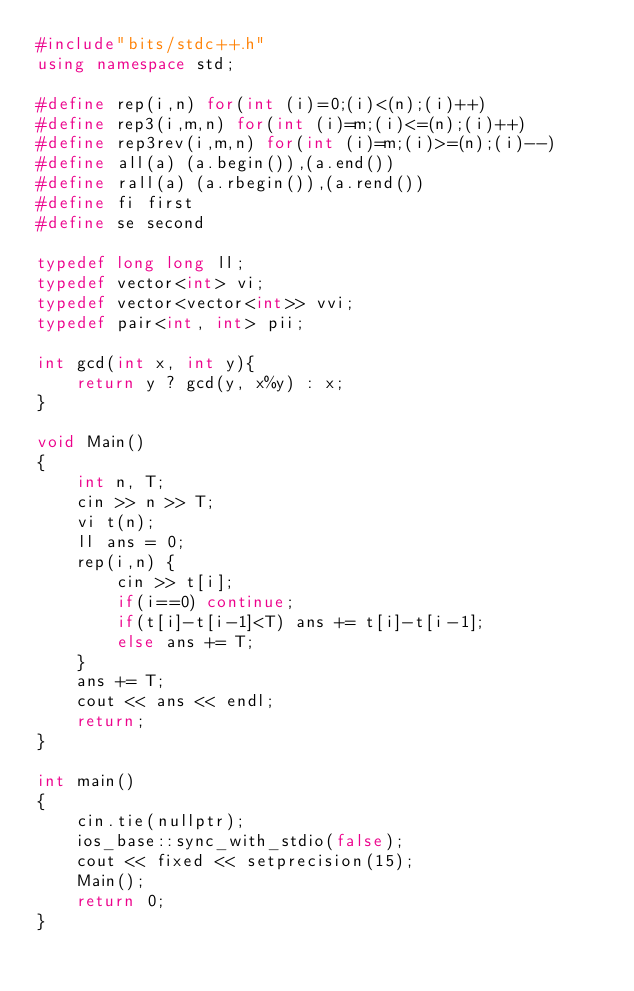<code> <loc_0><loc_0><loc_500><loc_500><_C++_>#include"bits/stdc++.h"
using namespace std;

#define rep(i,n) for(int (i)=0;(i)<(n);(i)++)
#define rep3(i,m,n) for(int (i)=m;(i)<=(n);(i)++)
#define rep3rev(i,m,n) for(int (i)=m;(i)>=(n);(i)--)
#define all(a) (a.begin()),(a.end())
#define rall(a) (a.rbegin()),(a.rend())
#define fi first
#define se second

typedef long long ll;
typedef vector<int> vi;
typedef vector<vector<int>> vvi;
typedef pair<int, int> pii;

int gcd(int x, int y){
	return y ? gcd(y, x%y) : x;
}

void Main()
{
	int n, T;
  	cin >> n >> T;
  	vi t(n);
  	ll ans = 0;
  	rep(i,n) {
      	cin >> t[i];
      	if(i==0) continue;
      	if(t[i]-t[i-1]<T) ans += t[i]-t[i-1];
      	else ans += T;
    }
  	ans += T;
  	cout << ans << endl;
	return;
}

int main()
{
	cin.tie(nullptr);
	ios_base::sync_with_stdio(false);
	cout << fixed << setprecision(15);
	Main();
	return 0;
}</code> 